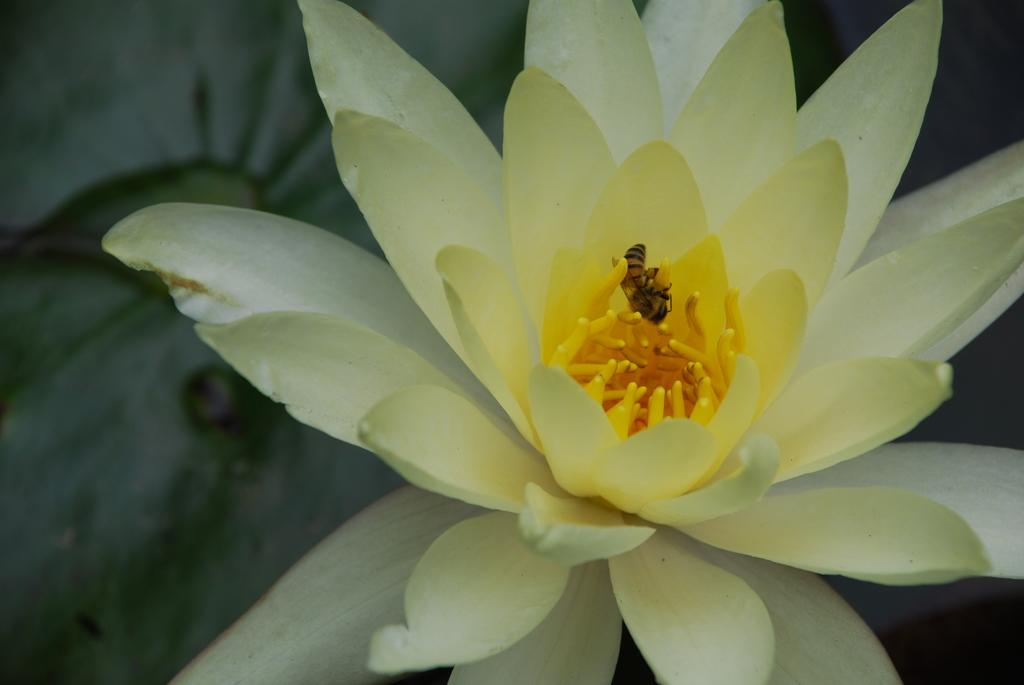What is the main subject of the image? There is a flower in the image. Can you describe the color of the flower? The flower is light green in color. What can be seen in the center of the flower? There is a yellow color in the middle of the flower. Is there anything above the flower in the image? Yes, there is an insect above the flower. What type of pickle is being used as a prop in the image? There is no pickle present in the image; it features a flower with an insect above it. What kind of art is being displayed in the image? The image does not show any art; it features a flower with an insect above it. 